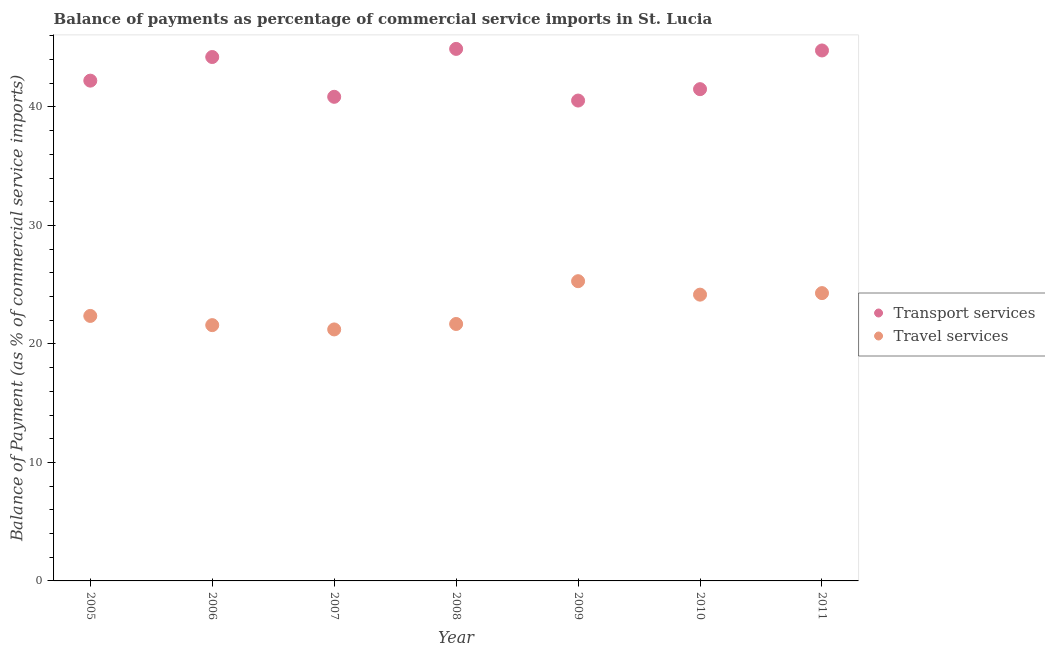Is the number of dotlines equal to the number of legend labels?
Provide a short and direct response. Yes. What is the balance of payments of travel services in 2010?
Offer a very short reply. 24.16. Across all years, what is the maximum balance of payments of transport services?
Give a very brief answer. 44.9. Across all years, what is the minimum balance of payments of travel services?
Give a very brief answer. 21.22. In which year was the balance of payments of transport services maximum?
Offer a very short reply. 2008. In which year was the balance of payments of travel services minimum?
Your response must be concise. 2007. What is the total balance of payments of transport services in the graph?
Provide a short and direct response. 298.99. What is the difference between the balance of payments of transport services in 2006 and that in 2008?
Give a very brief answer. -0.69. What is the difference between the balance of payments of travel services in 2010 and the balance of payments of transport services in 2006?
Ensure brevity in your answer.  -20.05. What is the average balance of payments of transport services per year?
Your answer should be compact. 42.71. In the year 2005, what is the difference between the balance of payments of transport services and balance of payments of travel services?
Give a very brief answer. 19.86. What is the ratio of the balance of payments of transport services in 2005 to that in 2008?
Your answer should be very brief. 0.94. What is the difference between the highest and the second highest balance of payments of transport services?
Ensure brevity in your answer.  0.13. What is the difference between the highest and the lowest balance of payments of travel services?
Give a very brief answer. 4.07. Is the sum of the balance of payments of transport services in 2006 and 2007 greater than the maximum balance of payments of travel services across all years?
Ensure brevity in your answer.  Yes. Is the balance of payments of transport services strictly less than the balance of payments of travel services over the years?
Your answer should be compact. No. How many dotlines are there?
Your response must be concise. 2. What is the difference between two consecutive major ticks on the Y-axis?
Give a very brief answer. 10. Does the graph contain grids?
Offer a terse response. No. Where does the legend appear in the graph?
Provide a short and direct response. Center right. How are the legend labels stacked?
Keep it short and to the point. Vertical. What is the title of the graph?
Provide a short and direct response. Balance of payments as percentage of commercial service imports in St. Lucia. Does "Import" appear as one of the legend labels in the graph?
Your answer should be very brief. No. What is the label or title of the Y-axis?
Your response must be concise. Balance of Payment (as % of commercial service imports). What is the Balance of Payment (as % of commercial service imports) of Transport services in 2005?
Offer a very short reply. 42.22. What is the Balance of Payment (as % of commercial service imports) in Travel services in 2005?
Offer a terse response. 22.36. What is the Balance of Payment (as % of commercial service imports) in Transport services in 2006?
Your answer should be compact. 44.21. What is the Balance of Payment (as % of commercial service imports) in Travel services in 2006?
Provide a succinct answer. 21.59. What is the Balance of Payment (as % of commercial service imports) in Transport services in 2007?
Keep it short and to the point. 40.85. What is the Balance of Payment (as % of commercial service imports) of Travel services in 2007?
Keep it short and to the point. 21.22. What is the Balance of Payment (as % of commercial service imports) of Transport services in 2008?
Keep it short and to the point. 44.9. What is the Balance of Payment (as % of commercial service imports) in Travel services in 2008?
Your answer should be compact. 21.68. What is the Balance of Payment (as % of commercial service imports) of Transport services in 2009?
Provide a short and direct response. 40.54. What is the Balance of Payment (as % of commercial service imports) of Travel services in 2009?
Your response must be concise. 25.29. What is the Balance of Payment (as % of commercial service imports) of Transport services in 2010?
Your answer should be compact. 41.5. What is the Balance of Payment (as % of commercial service imports) of Travel services in 2010?
Your answer should be very brief. 24.16. What is the Balance of Payment (as % of commercial service imports) in Transport services in 2011?
Keep it short and to the point. 44.77. What is the Balance of Payment (as % of commercial service imports) in Travel services in 2011?
Ensure brevity in your answer.  24.29. Across all years, what is the maximum Balance of Payment (as % of commercial service imports) of Transport services?
Your answer should be compact. 44.9. Across all years, what is the maximum Balance of Payment (as % of commercial service imports) in Travel services?
Offer a terse response. 25.29. Across all years, what is the minimum Balance of Payment (as % of commercial service imports) in Transport services?
Your response must be concise. 40.54. Across all years, what is the minimum Balance of Payment (as % of commercial service imports) of Travel services?
Ensure brevity in your answer.  21.22. What is the total Balance of Payment (as % of commercial service imports) of Transport services in the graph?
Offer a very short reply. 298.99. What is the total Balance of Payment (as % of commercial service imports) of Travel services in the graph?
Provide a short and direct response. 160.6. What is the difference between the Balance of Payment (as % of commercial service imports) of Transport services in 2005 and that in 2006?
Give a very brief answer. -1.99. What is the difference between the Balance of Payment (as % of commercial service imports) in Travel services in 2005 and that in 2006?
Your response must be concise. 0.78. What is the difference between the Balance of Payment (as % of commercial service imports) of Transport services in 2005 and that in 2007?
Provide a succinct answer. 1.36. What is the difference between the Balance of Payment (as % of commercial service imports) of Travel services in 2005 and that in 2007?
Offer a terse response. 1.14. What is the difference between the Balance of Payment (as % of commercial service imports) in Transport services in 2005 and that in 2008?
Provide a short and direct response. -2.68. What is the difference between the Balance of Payment (as % of commercial service imports) in Travel services in 2005 and that in 2008?
Provide a succinct answer. 0.68. What is the difference between the Balance of Payment (as % of commercial service imports) of Transport services in 2005 and that in 2009?
Ensure brevity in your answer.  1.68. What is the difference between the Balance of Payment (as % of commercial service imports) of Travel services in 2005 and that in 2009?
Give a very brief answer. -2.93. What is the difference between the Balance of Payment (as % of commercial service imports) in Transport services in 2005 and that in 2010?
Ensure brevity in your answer.  0.72. What is the difference between the Balance of Payment (as % of commercial service imports) in Travel services in 2005 and that in 2010?
Make the answer very short. -1.8. What is the difference between the Balance of Payment (as % of commercial service imports) in Transport services in 2005 and that in 2011?
Make the answer very short. -2.55. What is the difference between the Balance of Payment (as % of commercial service imports) in Travel services in 2005 and that in 2011?
Make the answer very short. -1.93. What is the difference between the Balance of Payment (as % of commercial service imports) in Transport services in 2006 and that in 2007?
Offer a very short reply. 3.36. What is the difference between the Balance of Payment (as % of commercial service imports) in Travel services in 2006 and that in 2007?
Your response must be concise. 0.36. What is the difference between the Balance of Payment (as % of commercial service imports) of Transport services in 2006 and that in 2008?
Your response must be concise. -0.69. What is the difference between the Balance of Payment (as % of commercial service imports) in Travel services in 2006 and that in 2008?
Make the answer very short. -0.1. What is the difference between the Balance of Payment (as % of commercial service imports) in Transport services in 2006 and that in 2009?
Give a very brief answer. 3.67. What is the difference between the Balance of Payment (as % of commercial service imports) in Travel services in 2006 and that in 2009?
Your response must be concise. -3.71. What is the difference between the Balance of Payment (as % of commercial service imports) of Transport services in 2006 and that in 2010?
Keep it short and to the point. 2.71. What is the difference between the Balance of Payment (as % of commercial service imports) of Travel services in 2006 and that in 2010?
Provide a short and direct response. -2.57. What is the difference between the Balance of Payment (as % of commercial service imports) of Transport services in 2006 and that in 2011?
Make the answer very short. -0.55. What is the difference between the Balance of Payment (as % of commercial service imports) in Travel services in 2006 and that in 2011?
Your answer should be very brief. -2.7. What is the difference between the Balance of Payment (as % of commercial service imports) in Transport services in 2007 and that in 2008?
Ensure brevity in your answer.  -4.04. What is the difference between the Balance of Payment (as % of commercial service imports) in Travel services in 2007 and that in 2008?
Provide a succinct answer. -0.46. What is the difference between the Balance of Payment (as % of commercial service imports) of Transport services in 2007 and that in 2009?
Make the answer very short. 0.32. What is the difference between the Balance of Payment (as % of commercial service imports) in Travel services in 2007 and that in 2009?
Your response must be concise. -4.07. What is the difference between the Balance of Payment (as % of commercial service imports) in Transport services in 2007 and that in 2010?
Offer a very short reply. -0.65. What is the difference between the Balance of Payment (as % of commercial service imports) of Travel services in 2007 and that in 2010?
Keep it short and to the point. -2.94. What is the difference between the Balance of Payment (as % of commercial service imports) of Transport services in 2007 and that in 2011?
Provide a short and direct response. -3.91. What is the difference between the Balance of Payment (as % of commercial service imports) in Travel services in 2007 and that in 2011?
Your response must be concise. -3.06. What is the difference between the Balance of Payment (as % of commercial service imports) of Transport services in 2008 and that in 2009?
Give a very brief answer. 4.36. What is the difference between the Balance of Payment (as % of commercial service imports) in Travel services in 2008 and that in 2009?
Offer a terse response. -3.61. What is the difference between the Balance of Payment (as % of commercial service imports) in Transport services in 2008 and that in 2010?
Your answer should be compact. 3.4. What is the difference between the Balance of Payment (as % of commercial service imports) of Travel services in 2008 and that in 2010?
Make the answer very short. -2.48. What is the difference between the Balance of Payment (as % of commercial service imports) of Transport services in 2008 and that in 2011?
Offer a terse response. 0.13. What is the difference between the Balance of Payment (as % of commercial service imports) of Travel services in 2008 and that in 2011?
Offer a very short reply. -2.6. What is the difference between the Balance of Payment (as % of commercial service imports) of Transport services in 2009 and that in 2010?
Your answer should be very brief. -0.96. What is the difference between the Balance of Payment (as % of commercial service imports) in Travel services in 2009 and that in 2010?
Offer a very short reply. 1.14. What is the difference between the Balance of Payment (as % of commercial service imports) of Transport services in 2009 and that in 2011?
Provide a succinct answer. -4.23. What is the difference between the Balance of Payment (as % of commercial service imports) of Transport services in 2010 and that in 2011?
Offer a terse response. -3.27. What is the difference between the Balance of Payment (as % of commercial service imports) of Travel services in 2010 and that in 2011?
Give a very brief answer. -0.13. What is the difference between the Balance of Payment (as % of commercial service imports) of Transport services in 2005 and the Balance of Payment (as % of commercial service imports) of Travel services in 2006?
Make the answer very short. 20.63. What is the difference between the Balance of Payment (as % of commercial service imports) of Transport services in 2005 and the Balance of Payment (as % of commercial service imports) of Travel services in 2007?
Make the answer very short. 21. What is the difference between the Balance of Payment (as % of commercial service imports) in Transport services in 2005 and the Balance of Payment (as % of commercial service imports) in Travel services in 2008?
Ensure brevity in your answer.  20.54. What is the difference between the Balance of Payment (as % of commercial service imports) in Transport services in 2005 and the Balance of Payment (as % of commercial service imports) in Travel services in 2009?
Your answer should be compact. 16.92. What is the difference between the Balance of Payment (as % of commercial service imports) of Transport services in 2005 and the Balance of Payment (as % of commercial service imports) of Travel services in 2010?
Your answer should be compact. 18.06. What is the difference between the Balance of Payment (as % of commercial service imports) of Transport services in 2005 and the Balance of Payment (as % of commercial service imports) of Travel services in 2011?
Give a very brief answer. 17.93. What is the difference between the Balance of Payment (as % of commercial service imports) of Transport services in 2006 and the Balance of Payment (as % of commercial service imports) of Travel services in 2007?
Your answer should be compact. 22.99. What is the difference between the Balance of Payment (as % of commercial service imports) of Transport services in 2006 and the Balance of Payment (as % of commercial service imports) of Travel services in 2008?
Provide a succinct answer. 22.53. What is the difference between the Balance of Payment (as % of commercial service imports) of Transport services in 2006 and the Balance of Payment (as % of commercial service imports) of Travel services in 2009?
Make the answer very short. 18.92. What is the difference between the Balance of Payment (as % of commercial service imports) of Transport services in 2006 and the Balance of Payment (as % of commercial service imports) of Travel services in 2010?
Offer a very short reply. 20.05. What is the difference between the Balance of Payment (as % of commercial service imports) in Transport services in 2006 and the Balance of Payment (as % of commercial service imports) in Travel services in 2011?
Your answer should be compact. 19.92. What is the difference between the Balance of Payment (as % of commercial service imports) in Transport services in 2007 and the Balance of Payment (as % of commercial service imports) in Travel services in 2008?
Make the answer very short. 19.17. What is the difference between the Balance of Payment (as % of commercial service imports) of Transport services in 2007 and the Balance of Payment (as % of commercial service imports) of Travel services in 2009?
Your answer should be very brief. 15.56. What is the difference between the Balance of Payment (as % of commercial service imports) in Transport services in 2007 and the Balance of Payment (as % of commercial service imports) in Travel services in 2010?
Ensure brevity in your answer.  16.7. What is the difference between the Balance of Payment (as % of commercial service imports) of Transport services in 2007 and the Balance of Payment (as % of commercial service imports) of Travel services in 2011?
Make the answer very short. 16.57. What is the difference between the Balance of Payment (as % of commercial service imports) in Transport services in 2008 and the Balance of Payment (as % of commercial service imports) in Travel services in 2009?
Offer a very short reply. 19.6. What is the difference between the Balance of Payment (as % of commercial service imports) in Transport services in 2008 and the Balance of Payment (as % of commercial service imports) in Travel services in 2010?
Offer a very short reply. 20.74. What is the difference between the Balance of Payment (as % of commercial service imports) of Transport services in 2008 and the Balance of Payment (as % of commercial service imports) of Travel services in 2011?
Provide a succinct answer. 20.61. What is the difference between the Balance of Payment (as % of commercial service imports) of Transport services in 2009 and the Balance of Payment (as % of commercial service imports) of Travel services in 2010?
Keep it short and to the point. 16.38. What is the difference between the Balance of Payment (as % of commercial service imports) of Transport services in 2009 and the Balance of Payment (as % of commercial service imports) of Travel services in 2011?
Keep it short and to the point. 16.25. What is the difference between the Balance of Payment (as % of commercial service imports) in Transport services in 2010 and the Balance of Payment (as % of commercial service imports) in Travel services in 2011?
Offer a very short reply. 17.21. What is the average Balance of Payment (as % of commercial service imports) in Transport services per year?
Ensure brevity in your answer.  42.71. What is the average Balance of Payment (as % of commercial service imports) in Travel services per year?
Offer a terse response. 22.94. In the year 2005, what is the difference between the Balance of Payment (as % of commercial service imports) of Transport services and Balance of Payment (as % of commercial service imports) of Travel services?
Offer a terse response. 19.86. In the year 2006, what is the difference between the Balance of Payment (as % of commercial service imports) of Transport services and Balance of Payment (as % of commercial service imports) of Travel services?
Your response must be concise. 22.63. In the year 2007, what is the difference between the Balance of Payment (as % of commercial service imports) in Transport services and Balance of Payment (as % of commercial service imports) in Travel services?
Give a very brief answer. 19.63. In the year 2008, what is the difference between the Balance of Payment (as % of commercial service imports) of Transport services and Balance of Payment (as % of commercial service imports) of Travel services?
Your answer should be compact. 23.21. In the year 2009, what is the difference between the Balance of Payment (as % of commercial service imports) in Transport services and Balance of Payment (as % of commercial service imports) in Travel services?
Make the answer very short. 15.24. In the year 2010, what is the difference between the Balance of Payment (as % of commercial service imports) in Transport services and Balance of Payment (as % of commercial service imports) in Travel services?
Keep it short and to the point. 17.34. In the year 2011, what is the difference between the Balance of Payment (as % of commercial service imports) in Transport services and Balance of Payment (as % of commercial service imports) in Travel services?
Keep it short and to the point. 20.48. What is the ratio of the Balance of Payment (as % of commercial service imports) of Transport services in 2005 to that in 2006?
Offer a terse response. 0.95. What is the ratio of the Balance of Payment (as % of commercial service imports) in Travel services in 2005 to that in 2006?
Your answer should be very brief. 1.04. What is the ratio of the Balance of Payment (as % of commercial service imports) in Transport services in 2005 to that in 2007?
Provide a succinct answer. 1.03. What is the ratio of the Balance of Payment (as % of commercial service imports) of Travel services in 2005 to that in 2007?
Offer a terse response. 1.05. What is the ratio of the Balance of Payment (as % of commercial service imports) in Transport services in 2005 to that in 2008?
Offer a terse response. 0.94. What is the ratio of the Balance of Payment (as % of commercial service imports) of Travel services in 2005 to that in 2008?
Provide a succinct answer. 1.03. What is the ratio of the Balance of Payment (as % of commercial service imports) in Transport services in 2005 to that in 2009?
Keep it short and to the point. 1.04. What is the ratio of the Balance of Payment (as % of commercial service imports) of Travel services in 2005 to that in 2009?
Your answer should be compact. 0.88. What is the ratio of the Balance of Payment (as % of commercial service imports) in Transport services in 2005 to that in 2010?
Provide a succinct answer. 1.02. What is the ratio of the Balance of Payment (as % of commercial service imports) in Travel services in 2005 to that in 2010?
Ensure brevity in your answer.  0.93. What is the ratio of the Balance of Payment (as % of commercial service imports) of Transport services in 2005 to that in 2011?
Make the answer very short. 0.94. What is the ratio of the Balance of Payment (as % of commercial service imports) in Travel services in 2005 to that in 2011?
Your response must be concise. 0.92. What is the ratio of the Balance of Payment (as % of commercial service imports) of Transport services in 2006 to that in 2007?
Your response must be concise. 1.08. What is the ratio of the Balance of Payment (as % of commercial service imports) in Travel services in 2006 to that in 2007?
Make the answer very short. 1.02. What is the ratio of the Balance of Payment (as % of commercial service imports) of Transport services in 2006 to that in 2008?
Offer a terse response. 0.98. What is the ratio of the Balance of Payment (as % of commercial service imports) of Travel services in 2006 to that in 2008?
Provide a short and direct response. 1. What is the ratio of the Balance of Payment (as % of commercial service imports) in Transport services in 2006 to that in 2009?
Offer a terse response. 1.09. What is the ratio of the Balance of Payment (as % of commercial service imports) in Travel services in 2006 to that in 2009?
Ensure brevity in your answer.  0.85. What is the ratio of the Balance of Payment (as % of commercial service imports) in Transport services in 2006 to that in 2010?
Your answer should be compact. 1.07. What is the ratio of the Balance of Payment (as % of commercial service imports) in Travel services in 2006 to that in 2010?
Keep it short and to the point. 0.89. What is the ratio of the Balance of Payment (as % of commercial service imports) of Transport services in 2006 to that in 2011?
Provide a short and direct response. 0.99. What is the ratio of the Balance of Payment (as % of commercial service imports) in Travel services in 2006 to that in 2011?
Your response must be concise. 0.89. What is the ratio of the Balance of Payment (as % of commercial service imports) in Transport services in 2007 to that in 2008?
Your answer should be compact. 0.91. What is the ratio of the Balance of Payment (as % of commercial service imports) in Travel services in 2007 to that in 2008?
Your response must be concise. 0.98. What is the ratio of the Balance of Payment (as % of commercial service imports) of Transport services in 2007 to that in 2009?
Your answer should be very brief. 1.01. What is the ratio of the Balance of Payment (as % of commercial service imports) of Travel services in 2007 to that in 2009?
Offer a very short reply. 0.84. What is the ratio of the Balance of Payment (as % of commercial service imports) in Transport services in 2007 to that in 2010?
Keep it short and to the point. 0.98. What is the ratio of the Balance of Payment (as % of commercial service imports) in Travel services in 2007 to that in 2010?
Your answer should be compact. 0.88. What is the ratio of the Balance of Payment (as % of commercial service imports) in Transport services in 2007 to that in 2011?
Ensure brevity in your answer.  0.91. What is the ratio of the Balance of Payment (as % of commercial service imports) of Travel services in 2007 to that in 2011?
Give a very brief answer. 0.87. What is the ratio of the Balance of Payment (as % of commercial service imports) of Transport services in 2008 to that in 2009?
Your answer should be compact. 1.11. What is the ratio of the Balance of Payment (as % of commercial service imports) in Travel services in 2008 to that in 2009?
Offer a very short reply. 0.86. What is the ratio of the Balance of Payment (as % of commercial service imports) of Transport services in 2008 to that in 2010?
Give a very brief answer. 1.08. What is the ratio of the Balance of Payment (as % of commercial service imports) in Travel services in 2008 to that in 2010?
Provide a short and direct response. 0.9. What is the ratio of the Balance of Payment (as % of commercial service imports) of Travel services in 2008 to that in 2011?
Make the answer very short. 0.89. What is the ratio of the Balance of Payment (as % of commercial service imports) in Transport services in 2009 to that in 2010?
Your response must be concise. 0.98. What is the ratio of the Balance of Payment (as % of commercial service imports) of Travel services in 2009 to that in 2010?
Keep it short and to the point. 1.05. What is the ratio of the Balance of Payment (as % of commercial service imports) in Transport services in 2009 to that in 2011?
Offer a terse response. 0.91. What is the ratio of the Balance of Payment (as % of commercial service imports) in Travel services in 2009 to that in 2011?
Make the answer very short. 1.04. What is the ratio of the Balance of Payment (as % of commercial service imports) of Transport services in 2010 to that in 2011?
Your answer should be very brief. 0.93. What is the difference between the highest and the second highest Balance of Payment (as % of commercial service imports) of Transport services?
Provide a succinct answer. 0.13. What is the difference between the highest and the lowest Balance of Payment (as % of commercial service imports) in Transport services?
Your answer should be very brief. 4.36. What is the difference between the highest and the lowest Balance of Payment (as % of commercial service imports) in Travel services?
Your response must be concise. 4.07. 